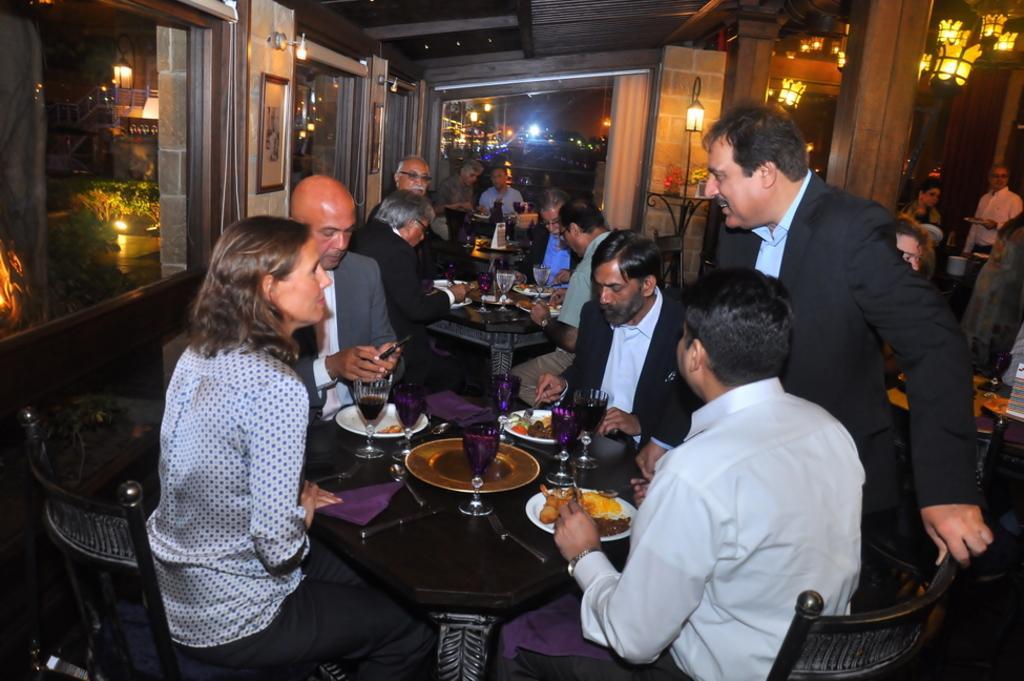Could you give a brief overview of what you see in this image? There are few people sitting on the chair at the table. There are plates,glasses,food items on the table. On the right a person is standing at the table. In the background there are frames on the wall,window,lights and few people. 